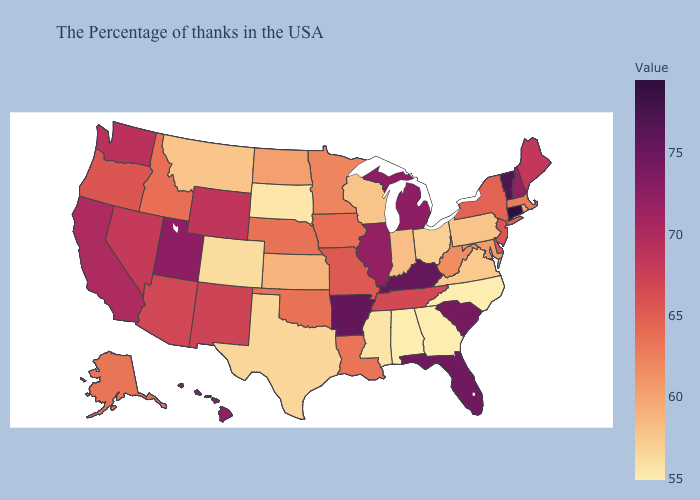Among the states that border California , does Nevada have the highest value?
Short answer required. Yes. Among the states that border Virginia , does North Carolina have the lowest value?
Answer briefly. Yes. Which states have the lowest value in the USA?
Keep it brief. North Carolina, Georgia, Alabama. Does Connecticut have the highest value in the USA?
Concise answer only. Yes. Which states have the lowest value in the Northeast?
Answer briefly. Pennsylvania. Among the states that border Oklahoma , which have the highest value?
Write a very short answer. Arkansas. Among the states that border Texas , does Louisiana have the highest value?
Be succinct. No. Which states have the highest value in the USA?
Concise answer only. Connecticut. 